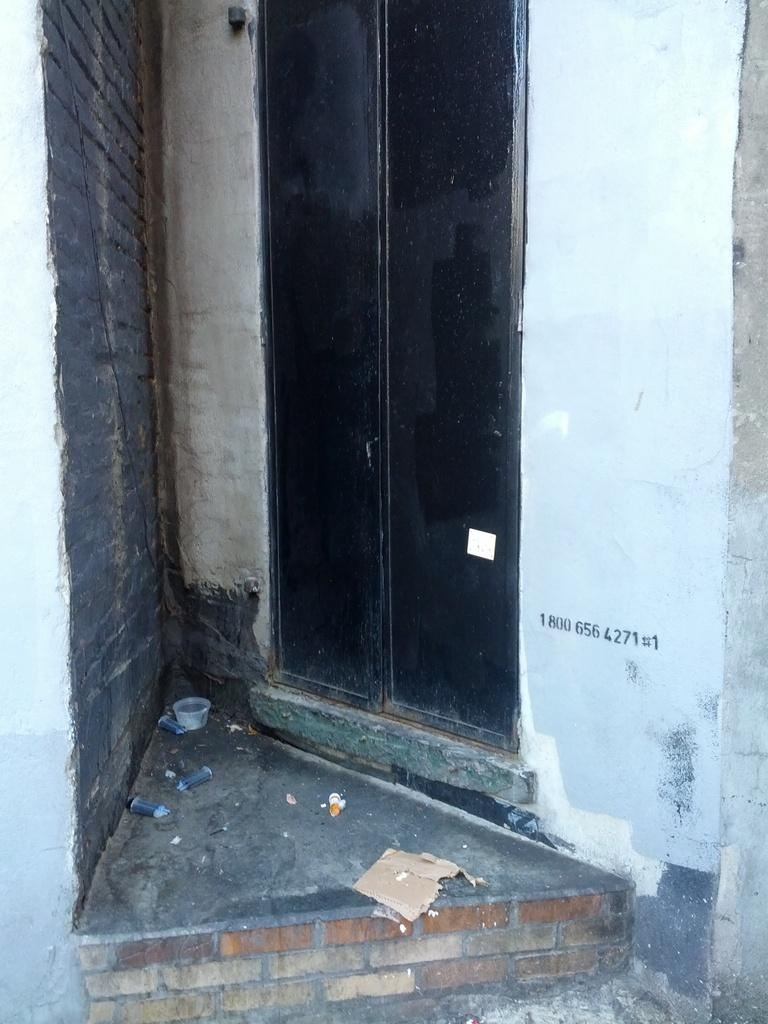What is the main object in the image? There is a door in the image. How is the door positioned in the image? The door is connected to a wall. Where is the nest located in the image? There is no nest present in the image. Is there a river flowing through the image? There is no river present in the image. 